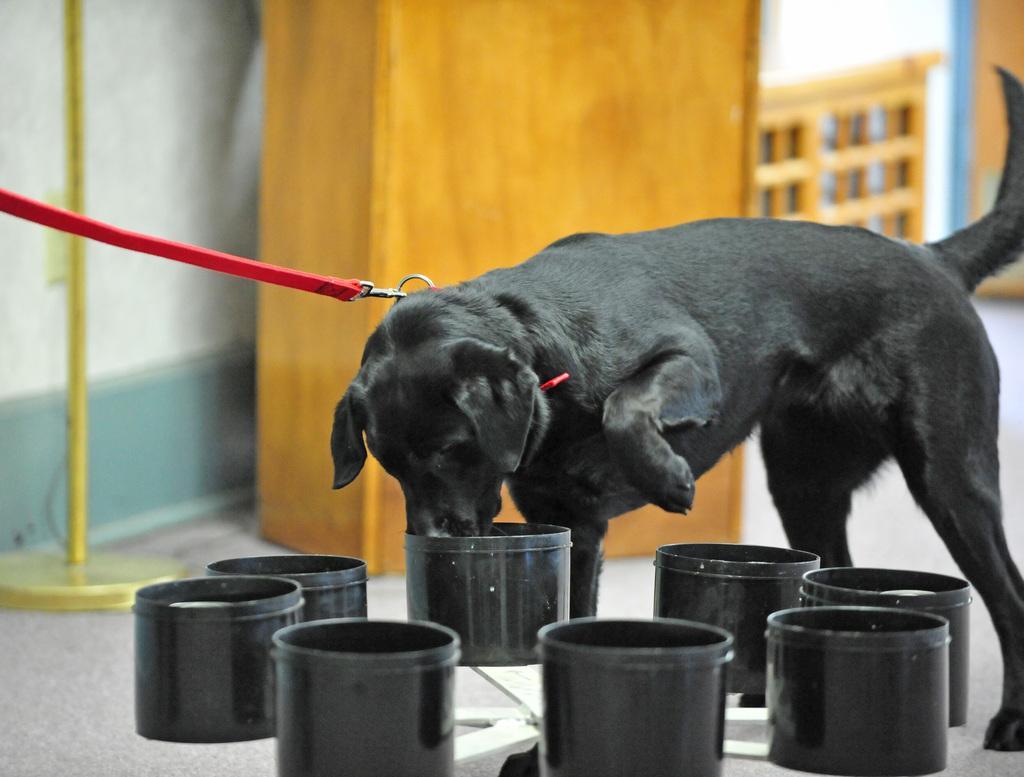In one or two sentences, can you explain what this image depicts? In this image we can see there is a dog tied with a leash and there are bowls and at the back we can see the wooden object and stand. And there is the wall. 